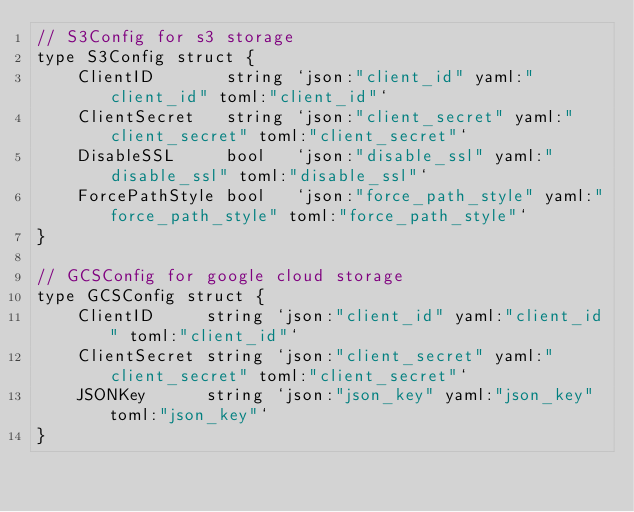Convert code to text. <code><loc_0><loc_0><loc_500><loc_500><_Go_>// S3Config for s3 storage
type S3Config struct {
	ClientID       string `json:"client_id" yaml:"client_id" toml:"client_id"`
	ClientSecret   string `json:"client_secret" yaml:"client_secret" toml:"client_secret"`
	DisableSSL     bool   `json:"disable_ssl" yaml:"disable_ssl" toml:"disable_ssl"`
	ForcePathStyle bool   `json:"force_path_style" yaml:"force_path_style" toml:"force_path_style"`
}

// GCSConfig for google cloud storage
type GCSConfig struct {
	ClientID     string `json:"client_id" yaml:"client_id" toml:"client_id"`
	ClientSecret string `json:"client_secret" yaml:"client_secret" toml:"client_secret"`
	JSONKey      string `json:"json_key" yaml:"json_key" toml:"json_key"`
}
</code> 